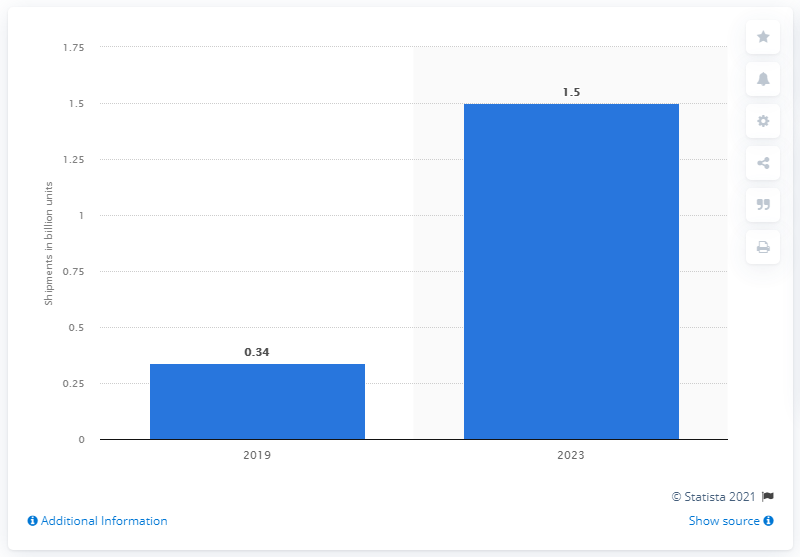Draw attention to some important aspects in this diagram. In 2019, global shipments of edge AI processors are expected to reach a total of 0.34 million units. 